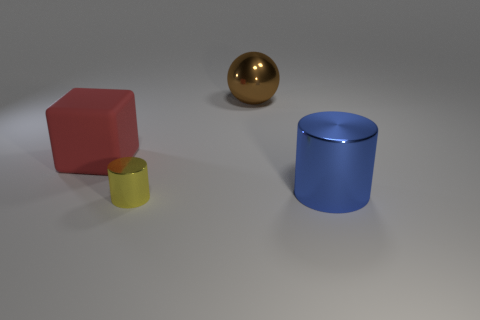There is a large thing that is the same shape as the tiny yellow shiny object; what is it made of?
Your response must be concise. Metal. The small metal cylinder has what color?
Your answer should be compact. Yellow. Do the big metallic ball and the large rubber object have the same color?
Offer a very short reply. No. How many rubber things are either tiny cylinders or small green balls?
Your answer should be very brief. 0. Is there a thing in front of the big thing right of the big brown metal object right of the small metal object?
Your answer should be compact. Yes. What size is the brown object that is the same material as the yellow object?
Provide a short and direct response. Large. Are there any small cylinders behind the small cylinder?
Provide a succinct answer. No. There is a big metallic thing that is in front of the big red cube; is there a metallic cylinder right of it?
Keep it short and to the point. No. There is a metallic cylinder right of the yellow metallic cylinder; is its size the same as the metal object in front of the blue metallic cylinder?
Your answer should be compact. No. How many tiny objects are blocks or balls?
Ensure brevity in your answer.  0. 